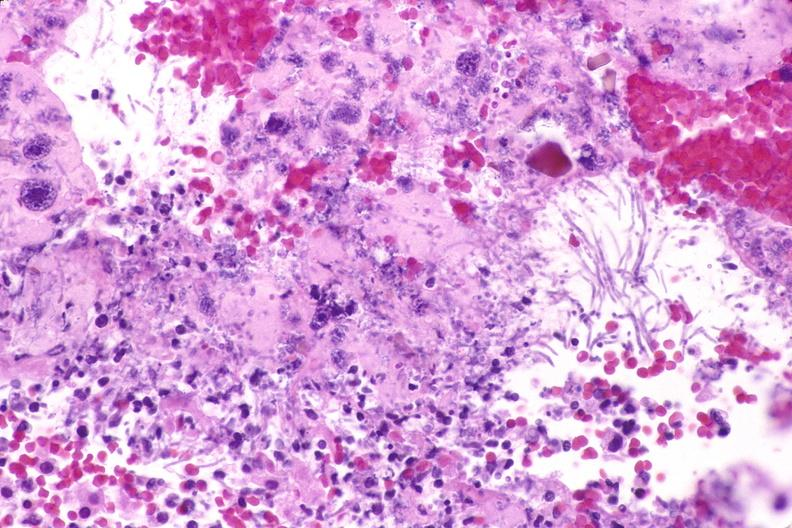does this image show esohagus, candida?
Answer the question using a single word or phrase. Yes 